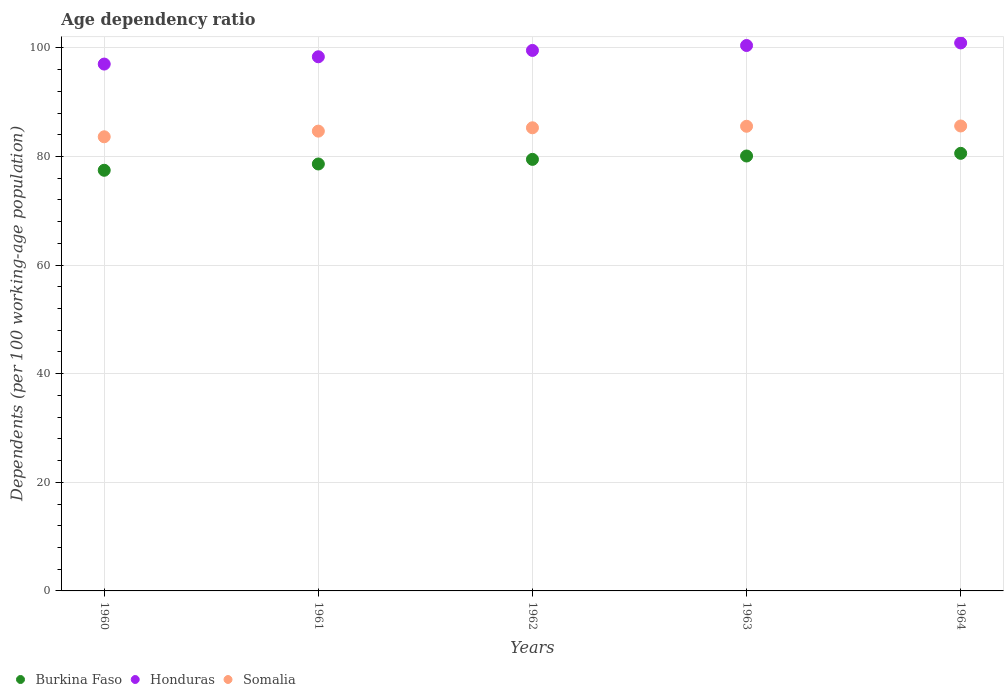What is the age dependency ratio in in Burkina Faso in 1961?
Provide a short and direct response. 78.62. Across all years, what is the maximum age dependency ratio in in Burkina Faso?
Offer a terse response. 80.58. Across all years, what is the minimum age dependency ratio in in Honduras?
Give a very brief answer. 97.02. In which year was the age dependency ratio in in Somalia maximum?
Your response must be concise. 1964. What is the total age dependency ratio in in Honduras in the graph?
Ensure brevity in your answer.  496.29. What is the difference between the age dependency ratio in in Honduras in 1962 and that in 1964?
Your answer should be compact. -1.38. What is the difference between the age dependency ratio in in Honduras in 1960 and the age dependency ratio in in Somalia in 1964?
Make the answer very short. 11.4. What is the average age dependency ratio in in Honduras per year?
Provide a succinct answer. 99.26. In the year 1962, what is the difference between the age dependency ratio in in Honduras and age dependency ratio in in Burkina Faso?
Your answer should be very brief. 20.06. What is the ratio of the age dependency ratio in in Somalia in 1960 to that in 1962?
Ensure brevity in your answer.  0.98. Is the age dependency ratio in in Somalia in 1961 less than that in 1962?
Offer a terse response. Yes. Is the difference between the age dependency ratio in in Honduras in 1960 and 1963 greater than the difference between the age dependency ratio in in Burkina Faso in 1960 and 1963?
Give a very brief answer. No. What is the difference between the highest and the second highest age dependency ratio in in Burkina Faso?
Give a very brief answer. 0.49. What is the difference between the highest and the lowest age dependency ratio in in Burkina Faso?
Provide a short and direct response. 3.12. Is the sum of the age dependency ratio in in Burkina Faso in 1962 and 1963 greater than the maximum age dependency ratio in in Honduras across all years?
Provide a succinct answer. Yes. Is it the case that in every year, the sum of the age dependency ratio in in Honduras and age dependency ratio in in Somalia  is greater than the age dependency ratio in in Burkina Faso?
Provide a succinct answer. Yes. Does the age dependency ratio in in Somalia monotonically increase over the years?
Keep it short and to the point. Yes. Is the age dependency ratio in in Somalia strictly less than the age dependency ratio in in Burkina Faso over the years?
Provide a short and direct response. No. What is the difference between two consecutive major ticks on the Y-axis?
Provide a short and direct response. 20. Are the values on the major ticks of Y-axis written in scientific E-notation?
Keep it short and to the point. No. Does the graph contain any zero values?
Provide a short and direct response. No. How many legend labels are there?
Provide a succinct answer. 3. How are the legend labels stacked?
Keep it short and to the point. Horizontal. What is the title of the graph?
Offer a terse response. Age dependency ratio. Does "Virgin Islands" appear as one of the legend labels in the graph?
Provide a succinct answer. No. What is the label or title of the X-axis?
Your answer should be very brief. Years. What is the label or title of the Y-axis?
Your answer should be compact. Dependents (per 100 working-age population). What is the Dependents (per 100 working-age population) of Burkina Faso in 1960?
Offer a very short reply. 77.47. What is the Dependents (per 100 working-age population) of Honduras in 1960?
Make the answer very short. 97.02. What is the Dependents (per 100 working-age population) in Somalia in 1960?
Provide a short and direct response. 83.63. What is the Dependents (per 100 working-age population) in Burkina Faso in 1961?
Make the answer very short. 78.62. What is the Dependents (per 100 working-age population) in Honduras in 1961?
Give a very brief answer. 98.37. What is the Dependents (per 100 working-age population) of Somalia in 1961?
Your answer should be very brief. 84.67. What is the Dependents (per 100 working-age population) of Burkina Faso in 1962?
Offer a very short reply. 79.47. What is the Dependents (per 100 working-age population) in Honduras in 1962?
Make the answer very short. 99.54. What is the Dependents (per 100 working-age population) in Somalia in 1962?
Your response must be concise. 85.29. What is the Dependents (per 100 working-age population) in Burkina Faso in 1963?
Your answer should be compact. 80.09. What is the Dependents (per 100 working-age population) in Honduras in 1963?
Your answer should be compact. 100.44. What is the Dependents (per 100 working-age population) in Somalia in 1963?
Ensure brevity in your answer.  85.57. What is the Dependents (per 100 working-age population) of Burkina Faso in 1964?
Keep it short and to the point. 80.58. What is the Dependents (per 100 working-age population) in Honduras in 1964?
Give a very brief answer. 100.91. What is the Dependents (per 100 working-age population) of Somalia in 1964?
Make the answer very short. 85.62. Across all years, what is the maximum Dependents (per 100 working-age population) in Burkina Faso?
Give a very brief answer. 80.58. Across all years, what is the maximum Dependents (per 100 working-age population) in Honduras?
Provide a succinct answer. 100.91. Across all years, what is the maximum Dependents (per 100 working-age population) in Somalia?
Your answer should be very brief. 85.62. Across all years, what is the minimum Dependents (per 100 working-age population) of Burkina Faso?
Ensure brevity in your answer.  77.47. Across all years, what is the minimum Dependents (per 100 working-age population) of Honduras?
Your answer should be compact. 97.02. Across all years, what is the minimum Dependents (per 100 working-age population) in Somalia?
Offer a terse response. 83.63. What is the total Dependents (per 100 working-age population) in Burkina Faso in the graph?
Offer a terse response. 396.24. What is the total Dependents (per 100 working-age population) in Honduras in the graph?
Your response must be concise. 496.29. What is the total Dependents (per 100 working-age population) in Somalia in the graph?
Offer a terse response. 424.79. What is the difference between the Dependents (per 100 working-age population) in Burkina Faso in 1960 and that in 1961?
Offer a very short reply. -1.16. What is the difference between the Dependents (per 100 working-age population) of Honduras in 1960 and that in 1961?
Ensure brevity in your answer.  -1.34. What is the difference between the Dependents (per 100 working-age population) in Somalia in 1960 and that in 1961?
Give a very brief answer. -1.04. What is the difference between the Dependents (per 100 working-age population) of Burkina Faso in 1960 and that in 1962?
Your answer should be compact. -2.01. What is the difference between the Dependents (per 100 working-age population) in Honduras in 1960 and that in 1962?
Provide a succinct answer. -2.51. What is the difference between the Dependents (per 100 working-age population) of Somalia in 1960 and that in 1962?
Make the answer very short. -1.66. What is the difference between the Dependents (per 100 working-age population) in Burkina Faso in 1960 and that in 1963?
Give a very brief answer. -2.63. What is the difference between the Dependents (per 100 working-age population) in Honduras in 1960 and that in 1963?
Give a very brief answer. -3.42. What is the difference between the Dependents (per 100 working-age population) of Somalia in 1960 and that in 1963?
Your answer should be very brief. -1.94. What is the difference between the Dependents (per 100 working-age population) of Burkina Faso in 1960 and that in 1964?
Make the answer very short. -3.12. What is the difference between the Dependents (per 100 working-age population) of Honduras in 1960 and that in 1964?
Make the answer very short. -3.89. What is the difference between the Dependents (per 100 working-age population) of Somalia in 1960 and that in 1964?
Keep it short and to the point. -1.99. What is the difference between the Dependents (per 100 working-age population) of Burkina Faso in 1961 and that in 1962?
Offer a very short reply. -0.85. What is the difference between the Dependents (per 100 working-age population) in Honduras in 1961 and that in 1962?
Give a very brief answer. -1.17. What is the difference between the Dependents (per 100 working-age population) in Somalia in 1961 and that in 1962?
Ensure brevity in your answer.  -0.62. What is the difference between the Dependents (per 100 working-age population) of Burkina Faso in 1961 and that in 1963?
Keep it short and to the point. -1.47. What is the difference between the Dependents (per 100 working-age population) in Honduras in 1961 and that in 1963?
Offer a terse response. -2.08. What is the difference between the Dependents (per 100 working-age population) in Somalia in 1961 and that in 1963?
Offer a terse response. -0.9. What is the difference between the Dependents (per 100 working-age population) in Burkina Faso in 1961 and that in 1964?
Make the answer very short. -1.96. What is the difference between the Dependents (per 100 working-age population) in Honduras in 1961 and that in 1964?
Offer a very short reply. -2.55. What is the difference between the Dependents (per 100 working-age population) in Somalia in 1961 and that in 1964?
Your answer should be very brief. -0.95. What is the difference between the Dependents (per 100 working-age population) of Burkina Faso in 1962 and that in 1963?
Your response must be concise. -0.62. What is the difference between the Dependents (per 100 working-age population) in Honduras in 1962 and that in 1963?
Keep it short and to the point. -0.9. What is the difference between the Dependents (per 100 working-age population) of Somalia in 1962 and that in 1963?
Provide a short and direct response. -0.28. What is the difference between the Dependents (per 100 working-age population) of Burkina Faso in 1962 and that in 1964?
Your answer should be very brief. -1.11. What is the difference between the Dependents (per 100 working-age population) of Honduras in 1962 and that in 1964?
Offer a terse response. -1.38. What is the difference between the Dependents (per 100 working-age population) of Somalia in 1962 and that in 1964?
Make the answer very short. -0.33. What is the difference between the Dependents (per 100 working-age population) of Burkina Faso in 1963 and that in 1964?
Keep it short and to the point. -0.49. What is the difference between the Dependents (per 100 working-age population) of Honduras in 1963 and that in 1964?
Offer a terse response. -0.47. What is the difference between the Dependents (per 100 working-age population) of Somalia in 1963 and that in 1964?
Keep it short and to the point. -0.05. What is the difference between the Dependents (per 100 working-age population) of Burkina Faso in 1960 and the Dependents (per 100 working-age population) of Honduras in 1961?
Your answer should be very brief. -20.9. What is the difference between the Dependents (per 100 working-age population) in Burkina Faso in 1960 and the Dependents (per 100 working-age population) in Somalia in 1961?
Your response must be concise. -7.21. What is the difference between the Dependents (per 100 working-age population) in Honduras in 1960 and the Dependents (per 100 working-age population) in Somalia in 1961?
Offer a terse response. 12.35. What is the difference between the Dependents (per 100 working-age population) in Burkina Faso in 1960 and the Dependents (per 100 working-age population) in Honduras in 1962?
Make the answer very short. -22.07. What is the difference between the Dependents (per 100 working-age population) of Burkina Faso in 1960 and the Dependents (per 100 working-age population) of Somalia in 1962?
Your answer should be compact. -7.82. What is the difference between the Dependents (per 100 working-age population) of Honduras in 1960 and the Dependents (per 100 working-age population) of Somalia in 1962?
Provide a short and direct response. 11.73. What is the difference between the Dependents (per 100 working-age population) in Burkina Faso in 1960 and the Dependents (per 100 working-age population) in Honduras in 1963?
Give a very brief answer. -22.98. What is the difference between the Dependents (per 100 working-age population) of Burkina Faso in 1960 and the Dependents (per 100 working-age population) of Somalia in 1963?
Provide a succinct answer. -8.1. What is the difference between the Dependents (per 100 working-age population) of Honduras in 1960 and the Dependents (per 100 working-age population) of Somalia in 1963?
Your response must be concise. 11.45. What is the difference between the Dependents (per 100 working-age population) of Burkina Faso in 1960 and the Dependents (per 100 working-age population) of Honduras in 1964?
Keep it short and to the point. -23.45. What is the difference between the Dependents (per 100 working-age population) of Burkina Faso in 1960 and the Dependents (per 100 working-age population) of Somalia in 1964?
Your response must be concise. -8.16. What is the difference between the Dependents (per 100 working-age population) of Honduras in 1960 and the Dependents (per 100 working-age population) of Somalia in 1964?
Provide a succinct answer. 11.4. What is the difference between the Dependents (per 100 working-age population) of Burkina Faso in 1961 and the Dependents (per 100 working-age population) of Honduras in 1962?
Provide a short and direct response. -20.91. What is the difference between the Dependents (per 100 working-age population) of Burkina Faso in 1961 and the Dependents (per 100 working-age population) of Somalia in 1962?
Ensure brevity in your answer.  -6.67. What is the difference between the Dependents (per 100 working-age population) of Honduras in 1961 and the Dependents (per 100 working-age population) of Somalia in 1962?
Offer a very short reply. 13.08. What is the difference between the Dependents (per 100 working-age population) in Burkina Faso in 1961 and the Dependents (per 100 working-age population) in Honduras in 1963?
Your answer should be very brief. -21.82. What is the difference between the Dependents (per 100 working-age population) in Burkina Faso in 1961 and the Dependents (per 100 working-age population) in Somalia in 1963?
Give a very brief answer. -6.95. What is the difference between the Dependents (per 100 working-age population) in Honduras in 1961 and the Dependents (per 100 working-age population) in Somalia in 1963?
Offer a very short reply. 12.8. What is the difference between the Dependents (per 100 working-age population) of Burkina Faso in 1961 and the Dependents (per 100 working-age population) of Honduras in 1964?
Provide a succinct answer. -22.29. What is the difference between the Dependents (per 100 working-age population) of Burkina Faso in 1961 and the Dependents (per 100 working-age population) of Somalia in 1964?
Your response must be concise. -7. What is the difference between the Dependents (per 100 working-age population) of Honduras in 1961 and the Dependents (per 100 working-age population) of Somalia in 1964?
Offer a terse response. 12.74. What is the difference between the Dependents (per 100 working-age population) in Burkina Faso in 1962 and the Dependents (per 100 working-age population) in Honduras in 1963?
Your response must be concise. -20.97. What is the difference between the Dependents (per 100 working-age population) of Burkina Faso in 1962 and the Dependents (per 100 working-age population) of Somalia in 1963?
Give a very brief answer. -6.1. What is the difference between the Dependents (per 100 working-age population) in Honduras in 1962 and the Dependents (per 100 working-age population) in Somalia in 1963?
Your answer should be very brief. 13.97. What is the difference between the Dependents (per 100 working-age population) in Burkina Faso in 1962 and the Dependents (per 100 working-age population) in Honduras in 1964?
Make the answer very short. -21.44. What is the difference between the Dependents (per 100 working-age population) of Burkina Faso in 1962 and the Dependents (per 100 working-age population) of Somalia in 1964?
Give a very brief answer. -6.15. What is the difference between the Dependents (per 100 working-age population) of Honduras in 1962 and the Dependents (per 100 working-age population) of Somalia in 1964?
Your response must be concise. 13.92. What is the difference between the Dependents (per 100 working-age population) of Burkina Faso in 1963 and the Dependents (per 100 working-age population) of Honduras in 1964?
Make the answer very short. -20.82. What is the difference between the Dependents (per 100 working-age population) of Burkina Faso in 1963 and the Dependents (per 100 working-age population) of Somalia in 1964?
Provide a short and direct response. -5.53. What is the difference between the Dependents (per 100 working-age population) of Honduras in 1963 and the Dependents (per 100 working-age population) of Somalia in 1964?
Keep it short and to the point. 14.82. What is the average Dependents (per 100 working-age population) in Burkina Faso per year?
Your response must be concise. 79.25. What is the average Dependents (per 100 working-age population) in Honduras per year?
Provide a succinct answer. 99.26. What is the average Dependents (per 100 working-age population) of Somalia per year?
Offer a terse response. 84.96. In the year 1960, what is the difference between the Dependents (per 100 working-age population) in Burkina Faso and Dependents (per 100 working-age population) in Honduras?
Offer a very short reply. -19.56. In the year 1960, what is the difference between the Dependents (per 100 working-age population) in Burkina Faso and Dependents (per 100 working-age population) in Somalia?
Provide a short and direct response. -6.17. In the year 1960, what is the difference between the Dependents (per 100 working-age population) of Honduras and Dependents (per 100 working-age population) of Somalia?
Provide a succinct answer. 13.39. In the year 1961, what is the difference between the Dependents (per 100 working-age population) of Burkina Faso and Dependents (per 100 working-age population) of Honduras?
Provide a succinct answer. -19.74. In the year 1961, what is the difference between the Dependents (per 100 working-age population) in Burkina Faso and Dependents (per 100 working-age population) in Somalia?
Give a very brief answer. -6.05. In the year 1961, what is the difference between the Dependents (per 100 working-age population) in Honduras and Dependents (per 100 working-age population) in Somalia?
Your answer should be compact. 13.69. In the year 1962, what is the difference between the Dependents (per 100 working-age population) in Burkina Faso and Dependents (per 100 working-age population) in Honduras?
Your answer should be compact. -20.06. In the year 1962, what is the difference between the Dependents (per 100 working-age population) of Burkina Faso and Dependents (per 100 working-age population) of Somalia?
Your answer should be very brief. -5.82. In the year 1962, what is the difference between the Dependents (per 100 working-age population) in Honduras and Dependents (per 100 working-age population) in Somalia?
Your response must be concise. 14.25. In the year 1963, what is the difference between the Dependents (per 100 working-age population) in Burkina Faso and Dependents (per 100 working-age population) in Honduras?
Your response must be concise. -20.35. In the year 1963, what is the difference between the Dependents (per 100 working-age population) in Burkina Faso and Dependents (per 100 working-age population) in Somalia?
Ensure brevity in your answer.  -5.48. In the year 1963, what is the difference between the Dependents (per 100 working-age population) of Honduras and Dependents (per 100 working-age population) of Somalia?
Ensure brevity in your answer.  14.87. In the year 1964, what is the difference between the Dependents (per 100 working-age population) in Burkina Faso and Dependents (per 100 working-age population) in Honduras?
Offer a terse response. -20.33. In the year 1964, what is the difference between the Dependents (per 100 working-age population) in Burkina Faso and Dependents (per 100 working-age population) in Somalia?
Provide a succinct answer. -5.04. In the year 1964, what is the difference between the Dependents (per 100 working-age population) of Honduras and Dependents (per 100 working-age population) of Somalia?
Offer a terse response. 15.29. What is the ratio of the Dependents (per 100 working-age population) of Honduras in 1960 to that in 1961?
Provide a succinct answer. 0.99. What is the ratio of the Dependents (per 100 working-age population) of Burkina Faso in 1960 to that in 1962?
Your response must be concise. 0.97. What is the ratio of the Dependents (per 100 working-age population) in Honduras in 1960 to that in 1962?
Offer a very short reply. 0.97. What is the ratio of the Dependents (per 100 working-age population) of Somalia in 1960 to that in 1962?
Provide a succinct answer. 0.98. What is the ratio of the Dependents (per 100 working-age population) of Burkina Faso in 1960 to that in 1963?
Provide a short and direct response. 0.97. What is the ratio of the Dependents (per 100 working-age population) of Honduras in 1960 to that in 1963?
Keep it short and to the point. 0.97. What is the ratio of the Dependents (per 100 working-age population) of Somalia in 1960 to that in 1963?
Provide a succinct answer. 0.98. What is the ratio of the Dependents (per 100 working-age population) in Burkina Faso in 1960 to that in 1964?
Make the answer very short. 0.96. What is the ratio of the Dependents (per 100 working-age population) in Honduras in 1960 to that in 1964?
Provide a short and direct response. 0.96. What is the ratio of the Dependents (per 100 working-age population) of Somalia in 1960 to that in 1964?
Provide a succinct answer. 0.98. What is the ratio of the Dependents (per 100 working-age population) of Burkina Faso in 1961 to that in 1962?
Give a very brief answer. 0.99. What is the ratio of the Dependents (per 100 working-age population) in Honduras in 1961 to that in 1962?
Give a very brief answer. 0.99. What is the ratio of the Dependents (per 100 working-age population) of Somalia in 1961 to that in 1962?
Provide a short and direct response. 0.99. What is the ratio of the Dependents (per 100 working-age population) of Burkina Faso in 1961 to that in 1963?
Offer a terse response. 0.98. What is the ratio of the Dependents (per 100 working-age population) in Honduras in 1961 to that in 1963?
Ensure brevity in your answer.  0.98. What is the ratio of the Dependents (per 100 working-age population) of Somalia in 1961 to that in 1963?
Make the answer very short. 0.99. What is the ratio of the Dependents (per 100 working-age population) of Burkina Faso in 1961 to that in 1964?
Give a very brief answer. 0.98. What is the ratio of the Dependents (per 100 working-age population) of Honduras in 1961 to that in 1964?
Provide a short and direct response. 0.97. What is the ratio of the Dependents (per 100 working-age population) of Somalia in 1961 to that in 1964?
Provide a succinct answer. 0.99. What is the ratio of the Dependents (per 100 working-age population) of Honduras in 1962 to that in 1963?
Give a very brief answer. 0.99. What is the ratio of the Dependents (per 100 working-age population) of Somalia in 1962 to that in 1963?
Ensure brevity in your answer.  1. What is the ratio of the Dependents (per 100 working-age population) of Burkina Faso in 1962 to that in 1964?
Offer a terse response. 0.99. What is the ratio of the Dependents (per 100 working-age population) of Honduras in 1962 to that in 1964?
Ensure brevity in your answer.  0.99. What is the ratio of the Dependents (per 100 working-age population) of Honduras in 1963 to that in 1964?
Give a very brief answer. 1. What is the ratio of the Dependents (per 100 working-age population) in Somalia in 1963 to that in 1964?
Ensure brevity in your answer.  1. What is the difference between the highest and the second highest Dependents (per 100 working-age population) in Burkina Faso?
Provide a short and direct response. 0.49. What is the difference between the highest and the second highest Dependents (per 100 working-age population) of Honduras?
Offer a very short reply. 0.47. What is the difference between the highest and the second highest Dependents (per 100 working-age population) in Somalia?
Offer a very short reply. 0.05. What is the difference between the highest and the lowest Dependents (per 100 working-age population) of Burkina Faso?
Make the answer very short. 3.12. What is the difference between the highest and the lowest Dependents (per 100 working-age population) of Honduras?
Offer a very short reply. 3.89. What is the difference between the highest and the lowest Dependents (per 100 working-age population) of Somalia?
Keep it short and to the point. 1.99. 